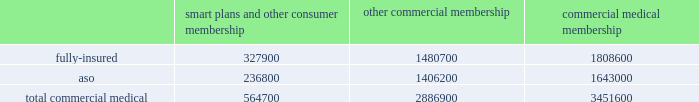We participate in a medicare health support pilot program through green ribbon health , or grh , a joint- venture company with pfizer health solutions inc .
Grh is designed to support medicare beneficiaries living with diabetes and/or congestive heart failure in central florida .
Grh uses disease management initiatives including evidence-based clinical guidelines , personal self-directed change strategies , and personal nurses to help participants navigate the health system .
Revenues under the contract with cms , which expires october 31 , 2008 unless terminated earlier , are subject to refund unless a savings target is met .
To date , all revenues have been deferred until reliable estimates are determinable .
Our products marketed to commercial segment employers and members smart plans and other consumer products over the last several years , we have developed and offered various commercial products designed to provide options and choices to employers that are annually facing substantial premium increases driven by double-digit medical cost inflation .
These smart plans , discussed more fully below , and other consumer offerings , which can be offered on either a fully-insured or aso basis , provided coverage to approximately 564700 members at december 31 , 2007 , representing approximately 16.4% ( 16.4 % ) of our total commercial medical membership as detailed below .
Smart plans and other consumer membership other commercial membership commercial medical membership .
These products are often offered to employer groups as 201cbundles 201d , where the subscribers are offered various hmo and ppo options , with various employer contribution strategies as determined by the employer .
Paramount to our product strategy , we have developed a group of innovative consumer products , styled as 201csmart 201d products , that we believe will be a long-term solution for employers .
We believe this new generation of products provides more ( 1 ) choices for the individual consumer , ( 2 ) transparency of provider costs , and ( 3 ) benefit designs that engage consumers in the costs and effectiveness of health care choices .
Innovative tools and technology are available to assist consumers with these decisions , including the trade-offs between higher premiums and point-of-service costs at the time consumers choose their plans , and to suggest ways in which the consumers can maximize their individual benefits at the point they use their plans .
We believe that when consumers can make informed choices about the cost and effectiveness of their health care , a sustainable long term solution for employers can be realized .
Smart products , which accounted for approximately 55% ( 55 % ) of enrollment in all of our consumer-choice plans as of december 31 , 2007 , are only sold to employers who use humana as their sole health insurance carrier .
Some employers have selected other types of consumer-choice products , such as , ( 1 ) a product with a high deductible , ( 2 ) a catastrophic coverage plan , or ( 3 ) ones that offer a spending account option in conjunction with more traditional medical coverage or as a stand alone plan .
Unlike our smart products , these products , while valuable in helping employers deal with near-term cost increases by shifting costs to employees , are not considered by us to be long-term comprehensive solutions to the employers 2019 cost dilemma , although we view them as an important interim step .
Our commercial hmo products provide prepaid health insurance coverage to our members through a network of independent primary care physicians , specialty physicians , and other health care providers who .
What was the percent of the fully-insured smart plans and other consumer membership to the total commercial medical? 
Rationale: 58% of the total commercial medical was the fully-insured smart plans and other consumer membership
Computations: (327900 / 564700)
Answer: 0.58066. 